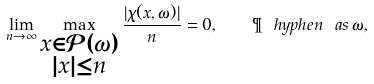Convert formula to latex. <formula><loc_0><loc_0><loc_500><loc_500>\lim _ { n \to \infty } \max _ { \substack { x \in \mathcal { P } ( \omega ) \\ | x | \leq n } } \frac { | \chi ( x , \omega ) | } { n } = 0 , \quad \P \ h y p h e n \ a s \, \omega ,</formula> 